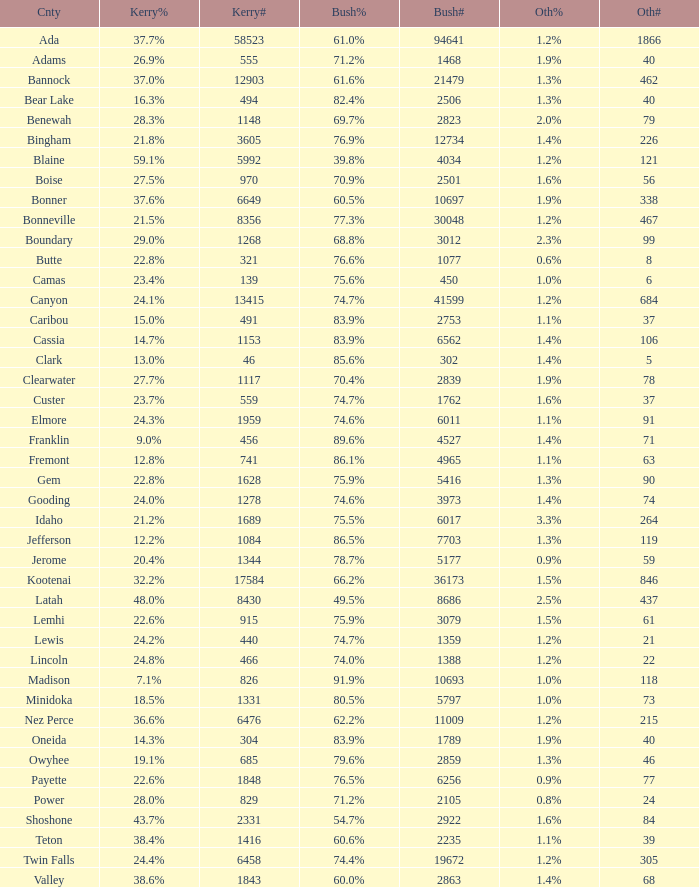What percentage of the votes were for others in the county where 462 people voted that way? 1.3%. 